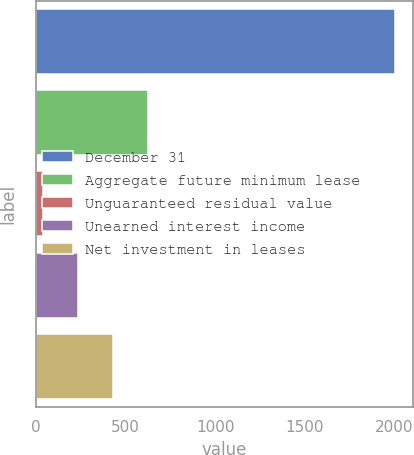Convert chart. <chart><loc_0><loc_0><loc_500><loc_500><bar_chart><fcel>December 31<fcel>Aggregate future minimum lease<fcel>Unguaranteed residual value<fcel>Unearned interest income<fcel>Net investment in leases<nl><fcel>2004<fcel>627.8<fcel>38<fcel>234.6<fcel>431.2<nl></chart> 